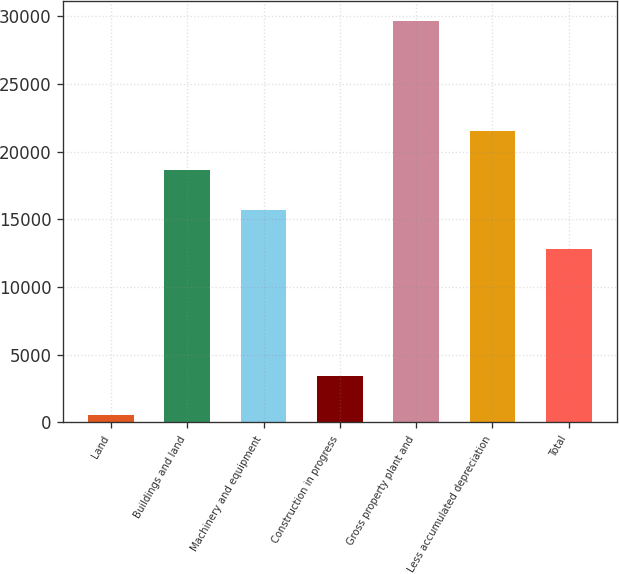Convert chart. <chart><loc_0><loc_0><loc_500><loc_500><bar_chart><fcel>Land<fcel>Buildings and land<fcel>Machinery and equipment<fcel>Construction in progress<fcel>Gross property plant and<fcel>Less accumulated depreciation<fcel>Total<nl><fcel>535<fcel>18638<fcel>15722.5<fcel>3450.5<fcel>29690<fcel>21553.5<fcel>12807<nl></chart> 